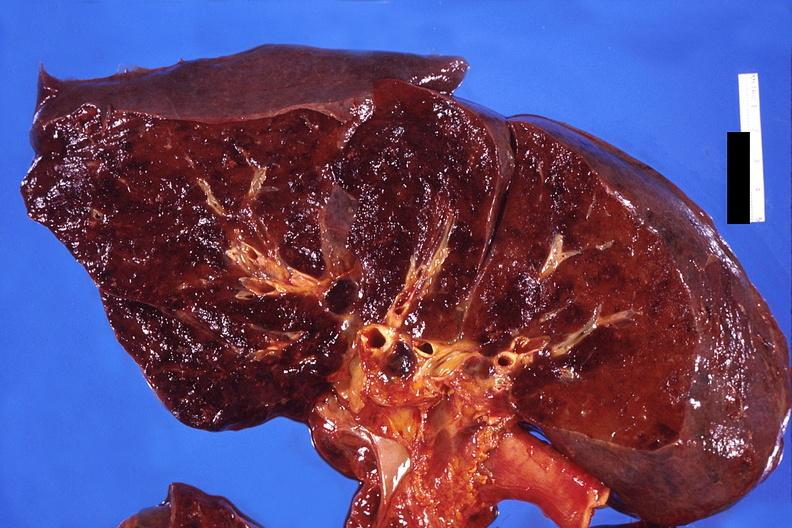does this image show lung, hemorrhagic bronchopneumonia, wilson 's disease?
Answer the question using a single word or phrase. Yes 